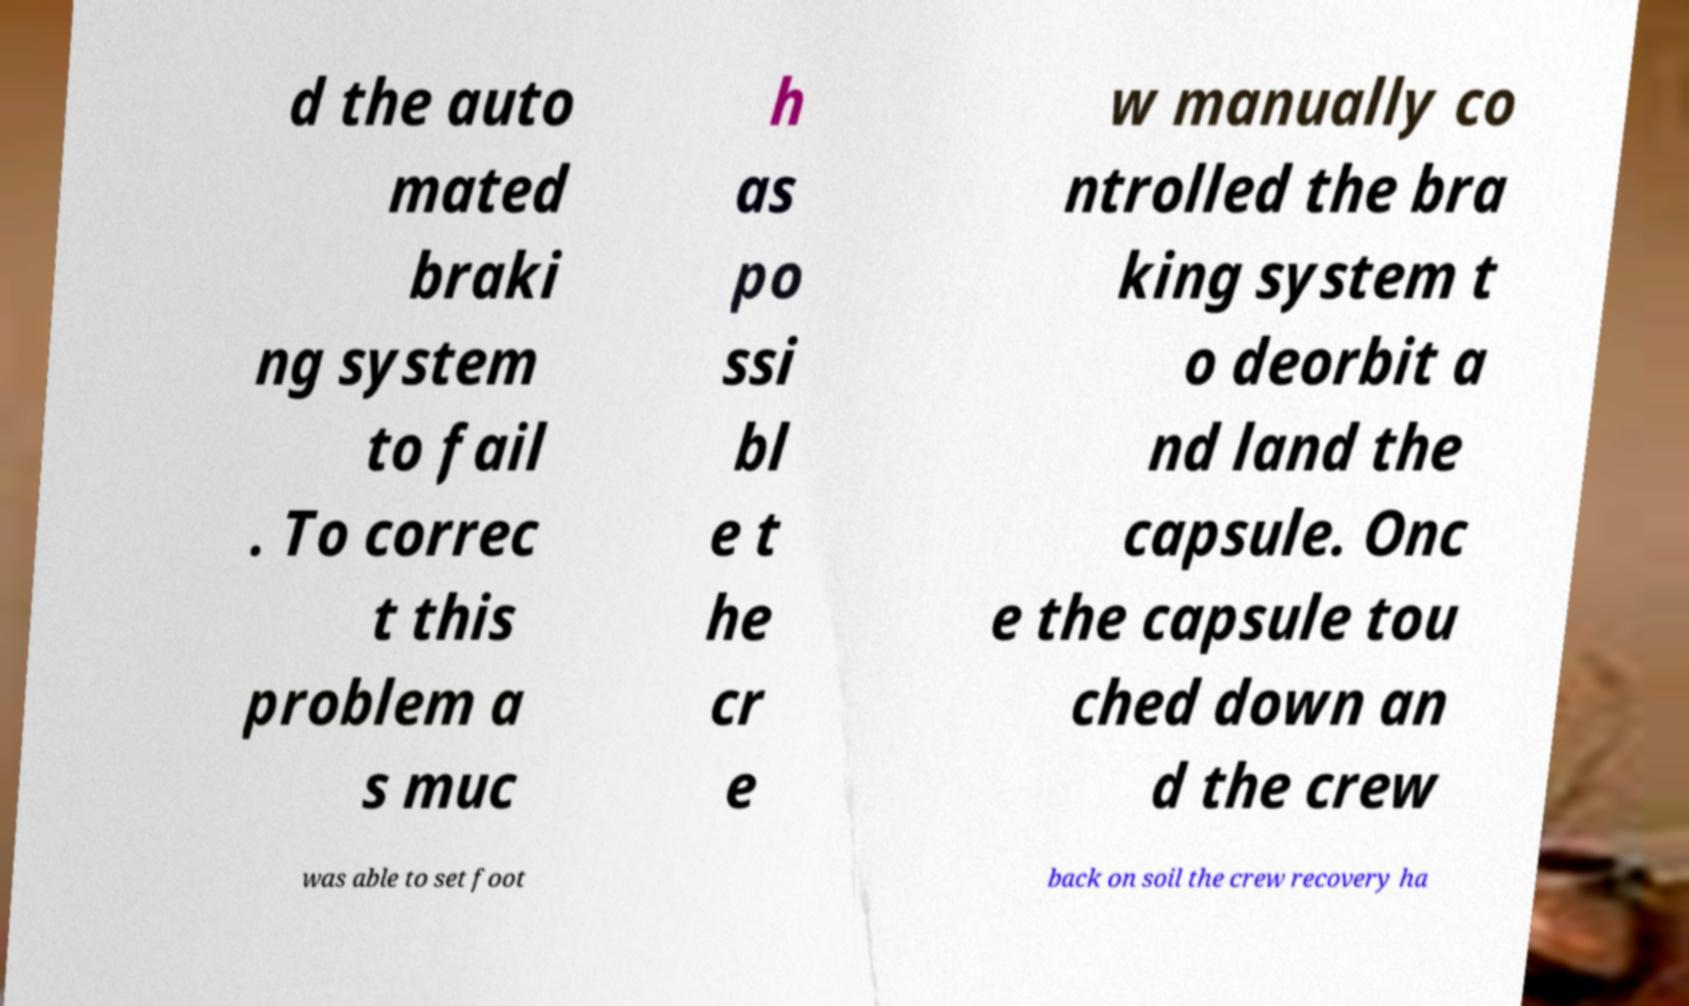Please read and relay the text visible in this image. What does it say? d the auto mated braki ng system to fail . To correc t this problem a s muc h as po ssi bl e t he cr e w manually co ntrolled the bra king system t o deorbit a nd land the capsule. Onc e the capsule tou ched down an d the crew was able to set foot back on soil the crew recovery ha 